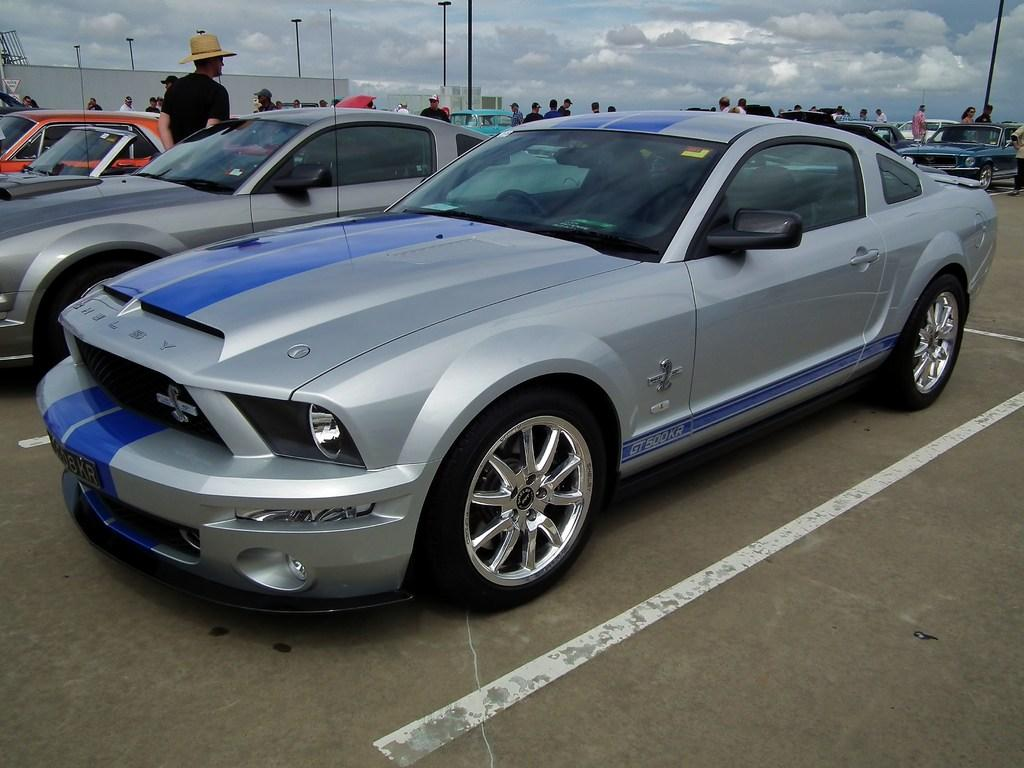What type of vehicles can be seen on the road in the image? There are cars on the road in the image. Can you describe the people in the image? There are people in the image, but their specific actions or appearances are not mentioned in the provided facts. What objects are present in the image that are not vehicles or people? There are poles in the image. What can be seen in the background of the image? There are buildings and the sky visible in the background of the image. Where is the tray of corn located in the image? There is no tray of corn present in the image. What type of creature is shown hiding in the cellar in the image? There is no cellar or creature present in the image. 